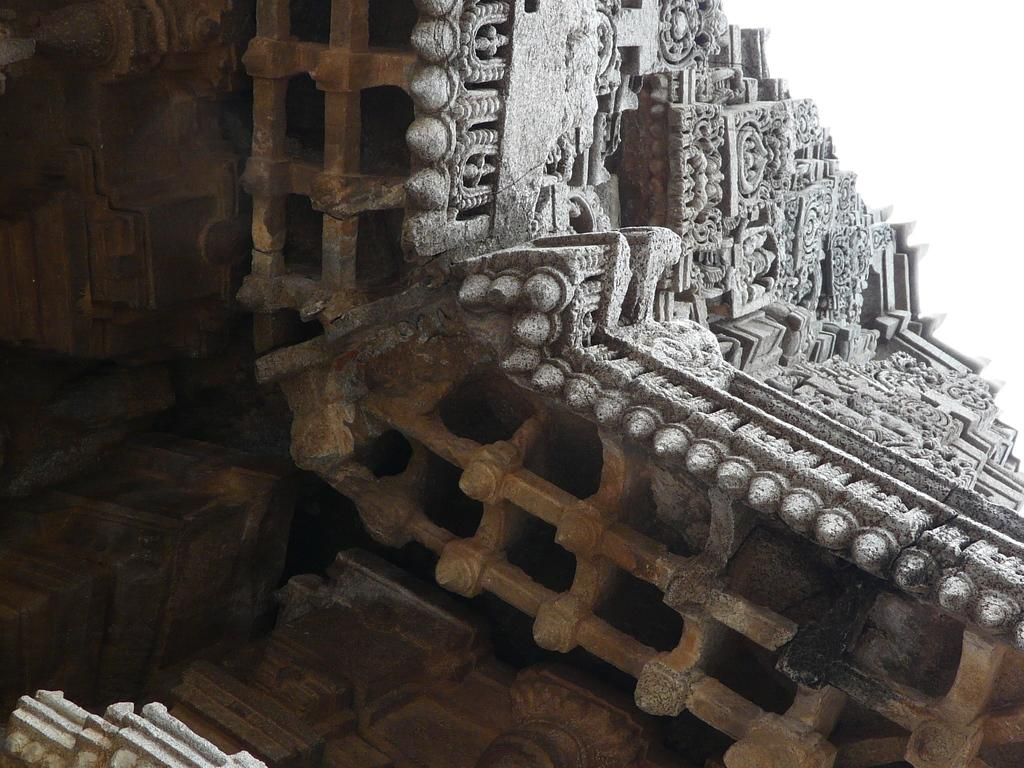What type of structure is shown in the image? The image depicts a temple. Are there any notable features on the temple's walls? Yes, beautiful carvings are present on the wall of the temple. What type of oil is used for the carvings on the temple walls? There is no information about oil being used for the carvings on the temple walls in the image. 